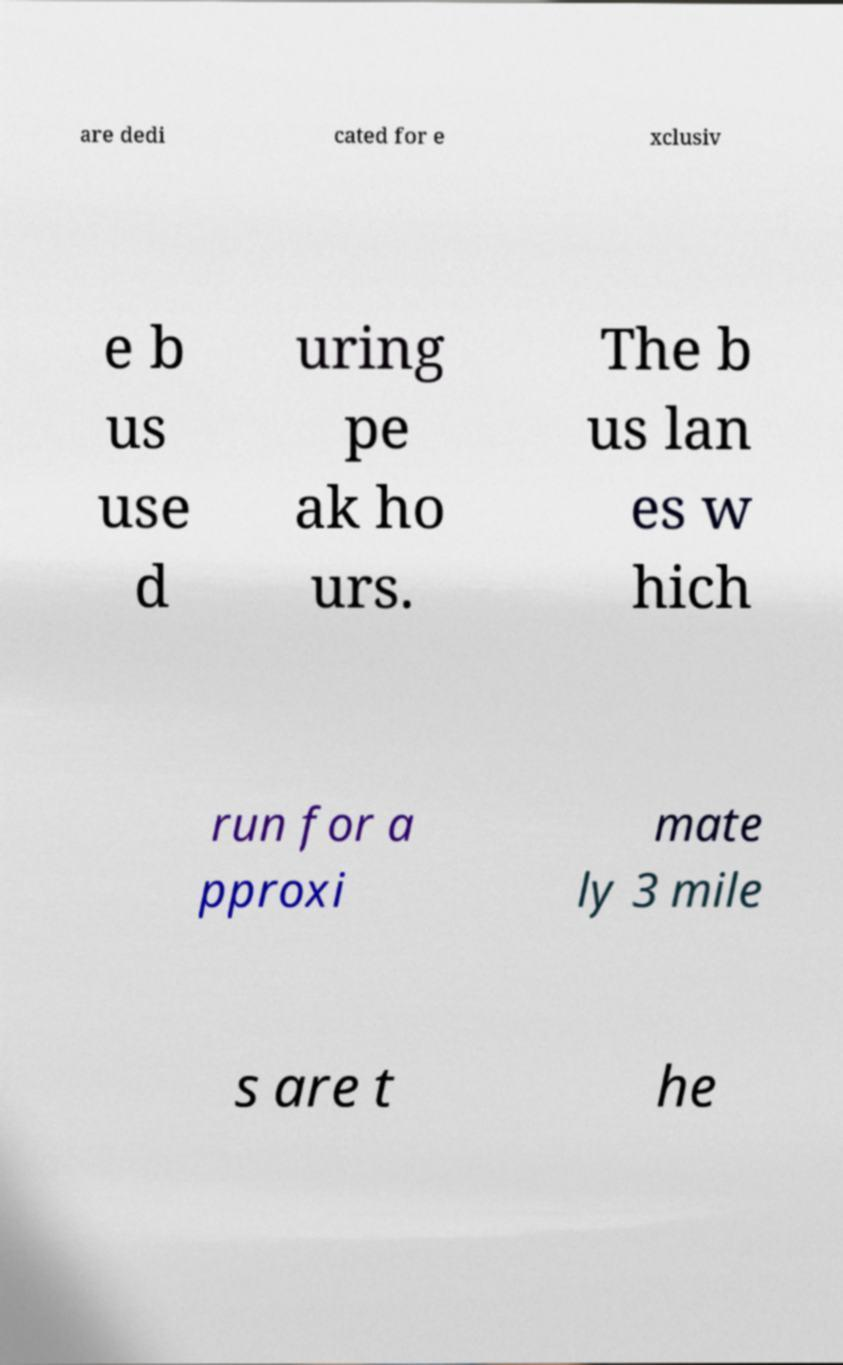Can you read and provide the text displayed in the image?This photo seems to have some interesting text. Can you extract and type it out for me? are dedi cated for e xclusiv e b us use d uring pe ak ho urs. The b us lan es w hich run for a pproxi mate ly 3 mile s are t he 